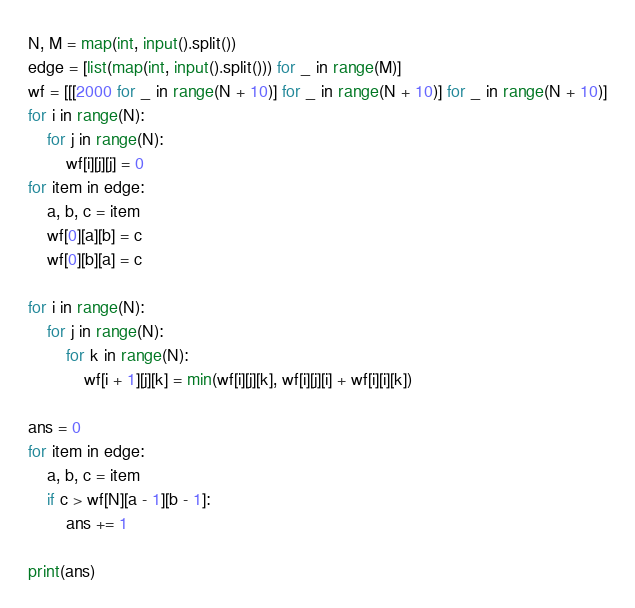<code> <loc_0><loc_0><loc_500><loc_500><_Python_>N, M = map(int, input().split())
edge = [list(map(int, input().split())) for _ in range(M)]
wf = [[[2000 for _ in range(N + 10)] for _ in range(N + 10)] for _ in range(N + 10)]
for i in range(N):
    for j in range(N):
        wf[i][j][j] = 0
for item in edge:
    a, b, c = item
    wf[0][a][b] = c
    wf[0][b][a] = c

for i in range(N):
    for j in range(N):
        for k in range(N):
            wf[i + 1][j][k] = min(wf[i][j][k], wf[i][j][i] + wf[i][i][k])

ans = 0
for item in edge:
    a, b, c = item
    if c > wf[N][a - 1][b - 1]:
        ans += 1

print(ans)</code> 